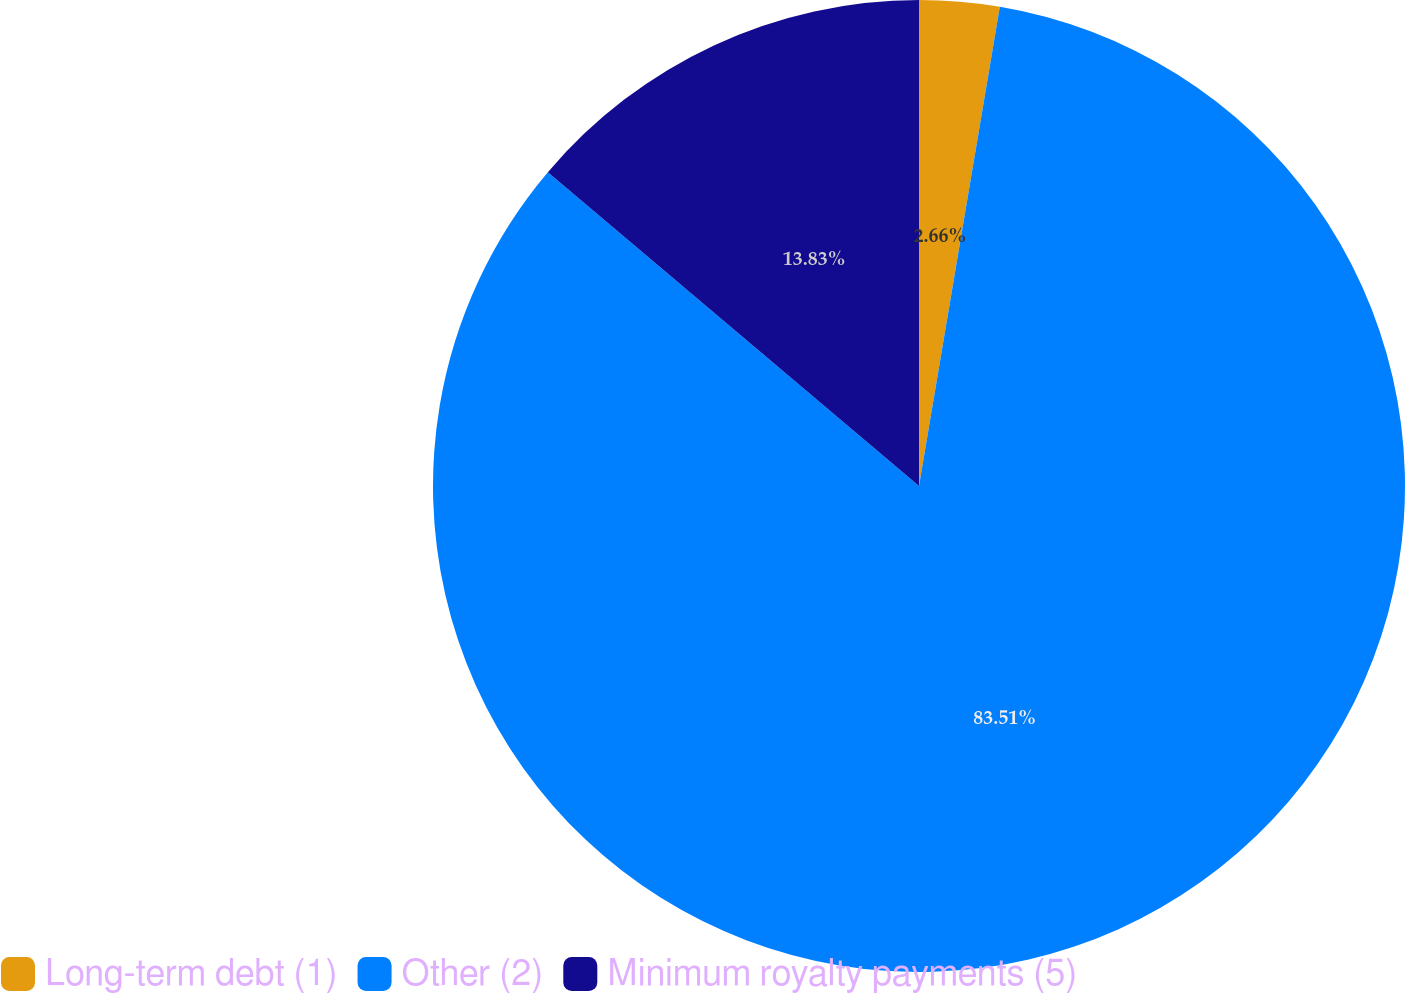Convert chart. <chart><loc_0><loc_0><loc_500><loc_500><pie_chart><fcel>Long-term debt (1)<fcel>Other (2)<fcel>Minimum royalty payments (5)<nl><fcel>2.66%<fcel>83.51%<fcel>13.83%<nl></chart> 